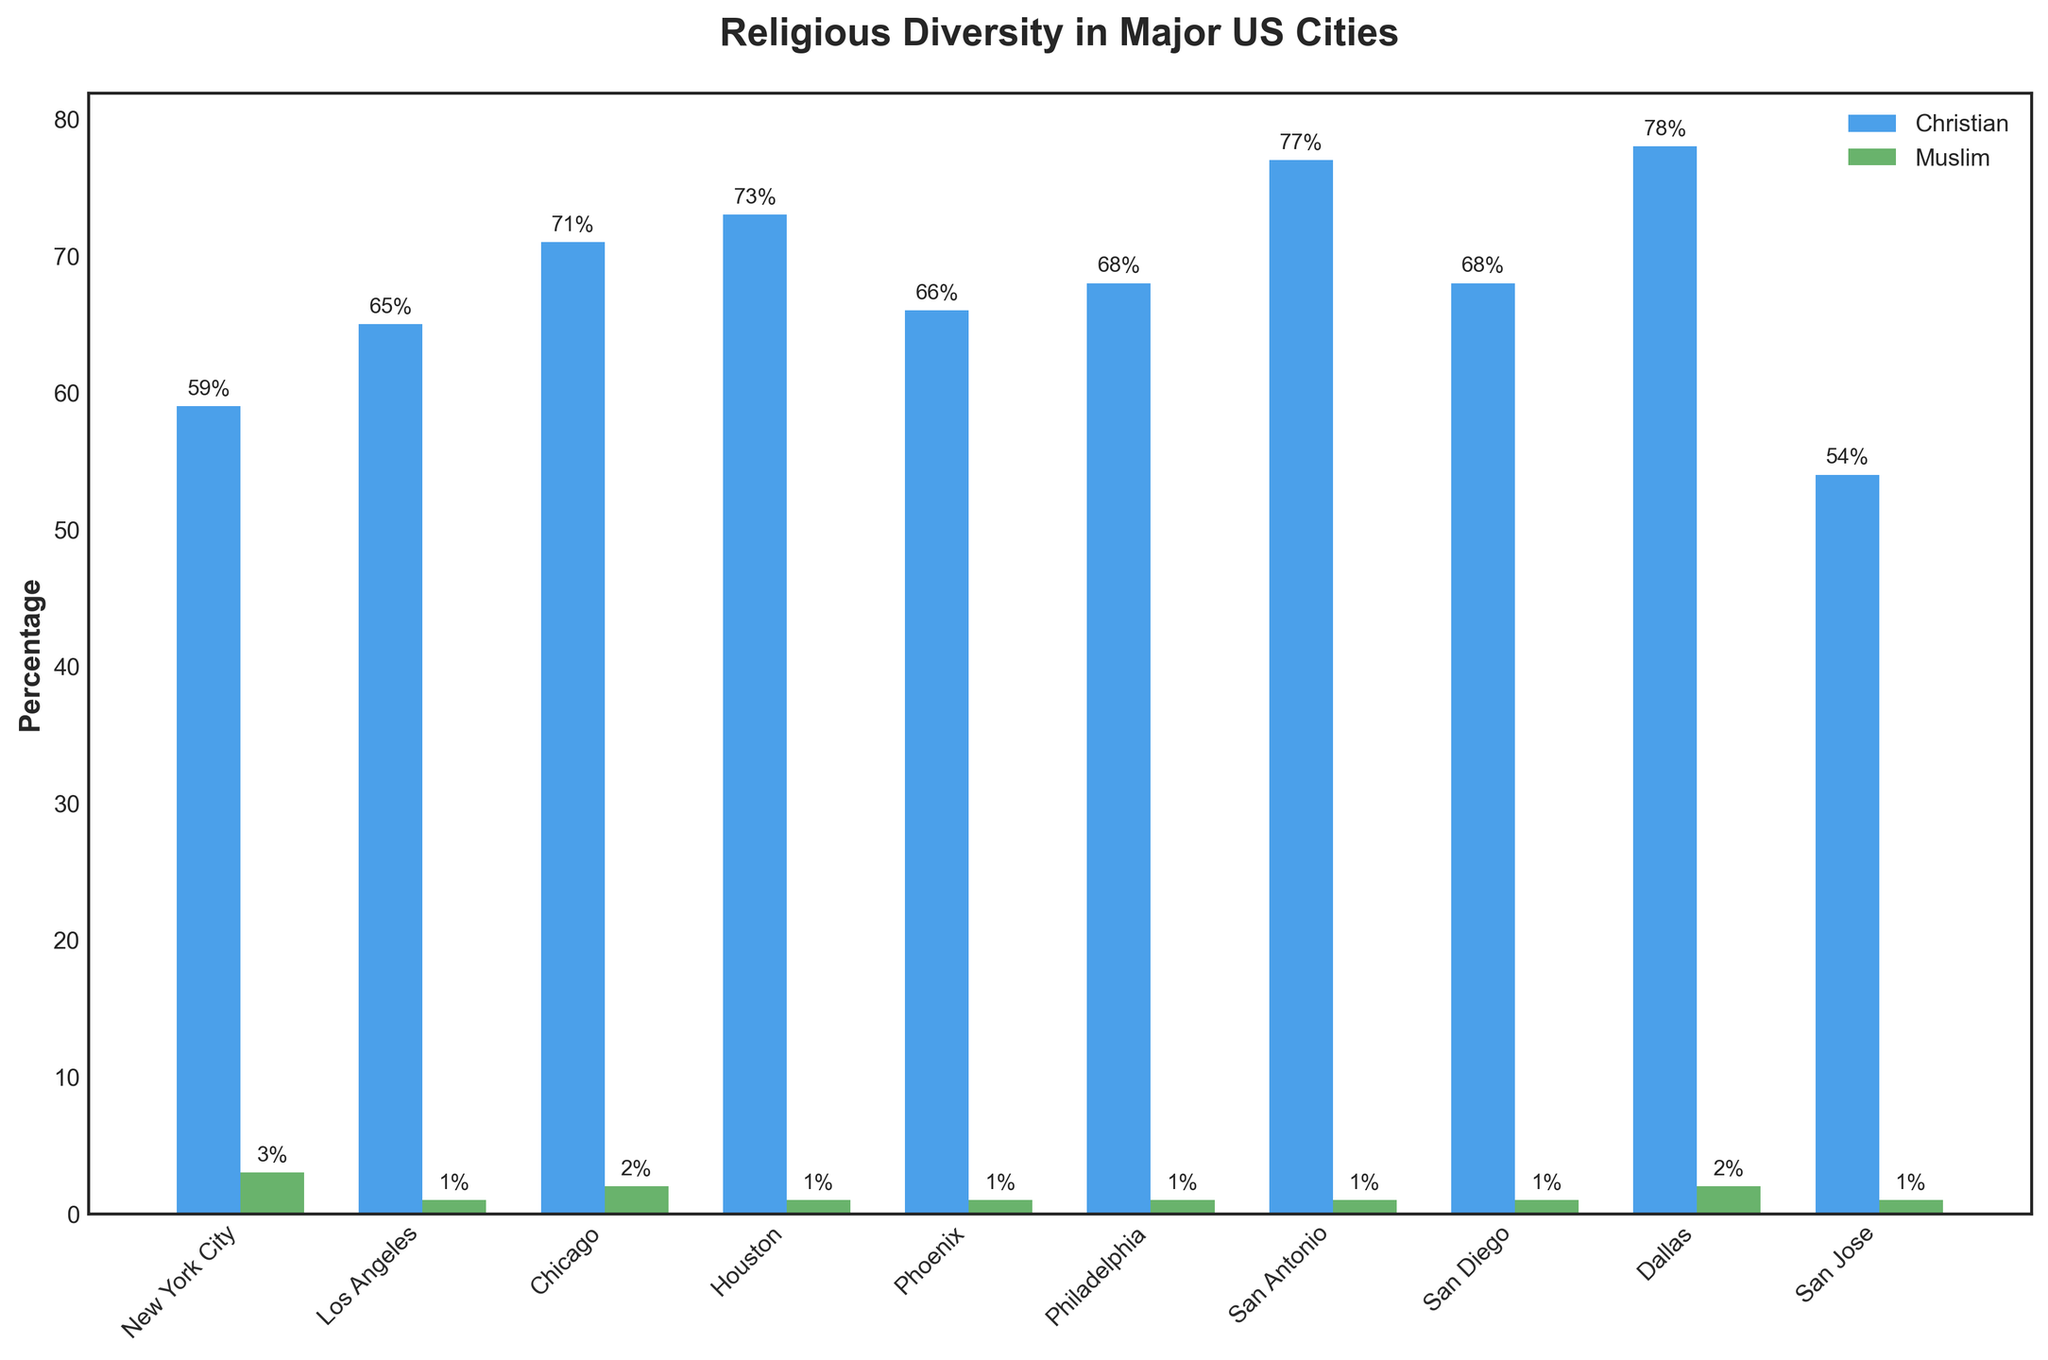Which city has the highest percentage of Muslims? Look at the height of the green bars representing Muslims. The highest green bar is in New York City.
Answer: New York City What's the difference in Christian population percentage between San Jose and Dallas? San Jose has 54% Christians while Dallas has 78%. The difference is 78% - 54% = 24%.
Answer: 24% Which city has a higher percentage of Christians, Chicago or Washington D.C.? Compare the heights of the blue bars for Chicago and Washington D.C. Chicago has 71% Christians while Washington D.C. has 65%.
Answer: Chicago What is the average percentage of Muslims in the top 10 cities? Add up the Muslim percentages for the top 10 cities: (3 + 1 + 2 + 1 + 1 + 1 + 1 + 1 + 2 + 1) = 14. Divide by 10: 14/10 = 1.4%.
Answer: 1.4% Which city has the lowest percentage of Christians among the top 10? Look for the shortest blue bar representing Christians. San Francisco is the lowest with 48%.
Answer: San Francisco What is the total percentage for Christians and Muslims combined in Los Angeles? Los Angeles has 65% Christians and 1% Muslims. Adding them gives 65% + 1% = 66%.
Answer: 66% How many cities in the top 10 have a higher percentage of Christians than Dallas? Dallas has 78% Christians. Only Jacksonville with 79% has a higher percentage. So, one city.
Answer: 1 Which two cities have the same percentage of Muslims? Look for cities with equal green bar heights representing Muslims. Los Angeles, Houston, Phoenix, Philadelphia, San Diego, San Jose, Austin, Columbus, Indianapolis, and Seattle all have 1%.
Answer: Multiple Cities What is the percentage difference of Muslims between New York City and Los Angeles? New York City has 3% Muslims while Los Angeles has 1%. The difference is 3% - 1% = 2%.
Answer: 2% Which city has more percentage of Muslims, Boston or Washington D.C.? Compare the green bars for Boston and Washington D.C. Both have a percentage of 2%.
Answer: Equal 